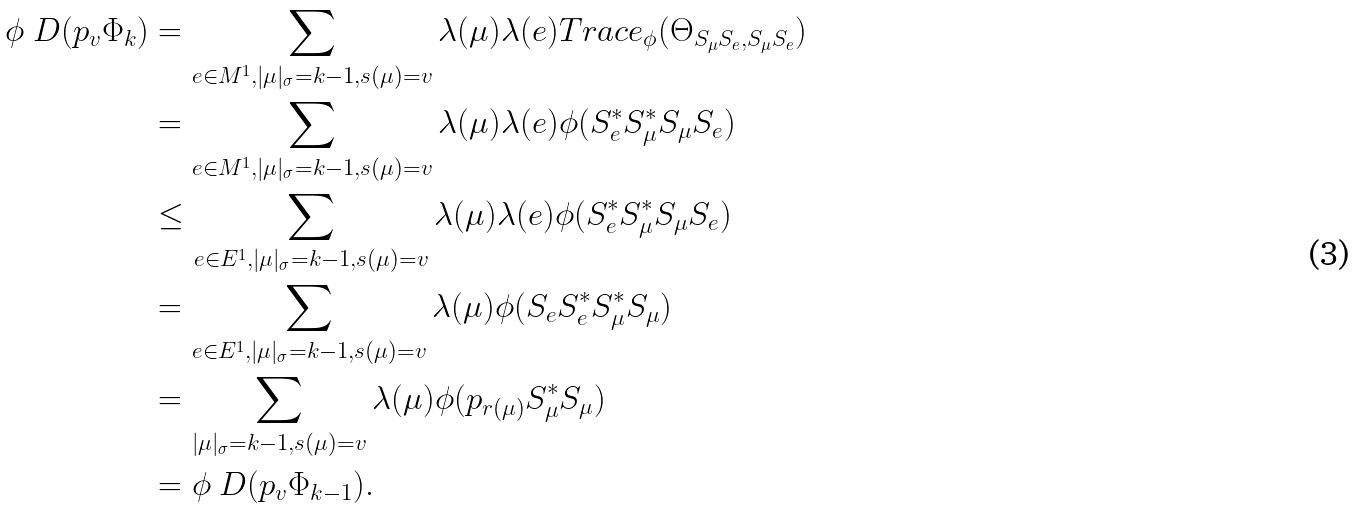Convert formula to latex. <formula><loc_0><loc_0><loc_500><loc_500>\phi _ { \ } D ( p _ { v } \Phi _ { k } ) & = \sum _ { e \in M ^ { 1 } , | \mu | _ { \sigma } = k - 1 , s ( \mu ) = v } \lambda ( \mu ) \lambda ( e ) T r a c e _ { \phi } ( \Theta _ { S _ { \mu } S _ { e } , S _ { \mu } S _ { e } } ) \\ & = \sum _ { e \in M ^ { 1 } , | \mu | _ { \sigma } = k - 1 , s ( \mu ) = v } \lambda ( \mu ) \lambda ( e ) \phi ( S _ { e } ^ { * } S _ { \mu } ^ { * } S _ { \mu } S _ { e } ) \\ & \leq \sum _ { e \in E ^ { 1 } , | \mu | _ { \sigma } = k - 1 , s ( \mu ) = v } \lambda ( \mu ) \lambda ( e ) \phi ( S _ { e } ^ { * } S _ { \mu } ^ { * } S _ { \mu } S _ { e } ) \\ & = \sum _ { e \in E ^ { 1 } , | \mu | _ { \sigma } = k - 1 , s ( \mu ) = v } \lambda ( \mu ) \phi ( S _ { e } S _ { e } ^ { * } S _ { \mu } ^ { * } S _ { \mu } ) \\ & = \sum _ { | \mu | _ { \sigma } = k - 1 , s ( \mu ) = v } \lambda ( \mu ) \phi ( p _ { r ( \mu ) } S _ { \mu } ^ { * } S _ { \mu } ) \\ & = \phi _ { \ } D ( p _ { v } \Phi _ { k - 1 } ) .</formula> 